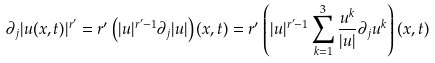Convert formula to latex. <formula><loc_0><loc_0><loc_500><loc_500>\partial _ { j } | u ( x , t ) | ^ { r ^ { \prime } } = r ^ { \prime } \left ( | u | ^ { r ^ { \prime } - 1 } \partial _ { j } | u | \right ) ( x , t ) = r ^ { \prime } \left ( | u | ^ { r ^ { \prime } - 1 } \sum _ { k = 1 } ^ { 3 } \frac { u ^ { k } } { | u | } \partial _ { j } u ^ { k } \right ) ( x , t )</formula> 